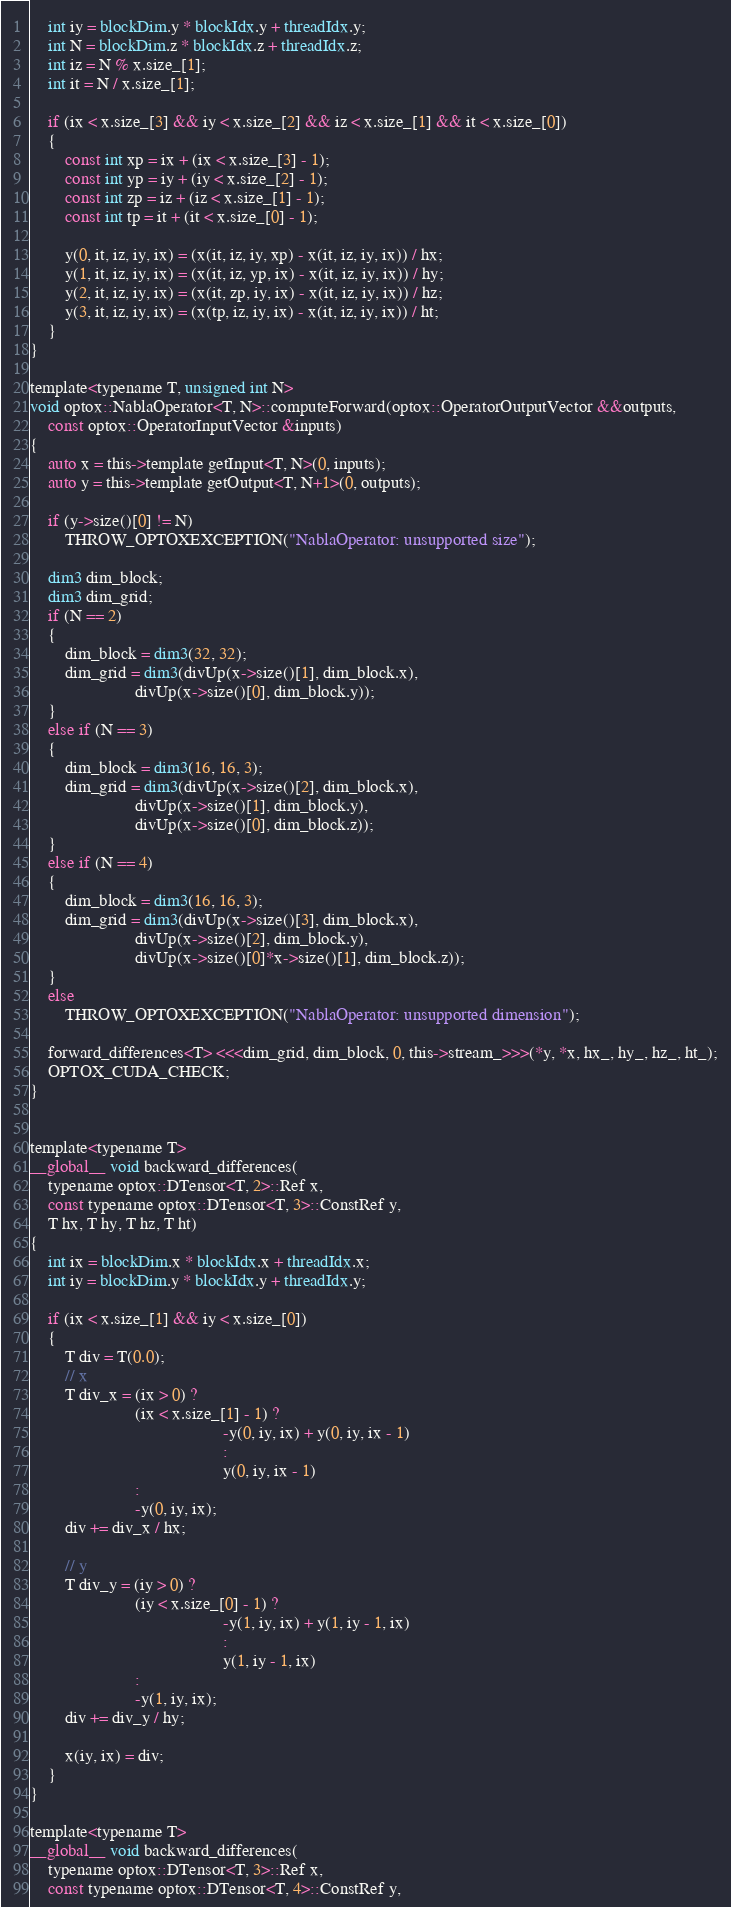Convert code to text. <code><loc_0><loc_0><loc_500><loc_500><_Cuda_>    int iy = blockDim.y * blockIdx.y + threadIdx.y;
    int N = blockDim.z * blockIdx.z + threadIdx.z;
    int iz = N % x.size_[1];
    int it = N / x.size_[1];
  
    if (ix < x.size_[3] && iy < x.size_[2] && iz < x.size_[1] && it < x.size_[0])
    {
        const int xp = ix + (ix < x.size_[3] - 1);
        const int yp = iy + (iy < x.size_[2] - 1);
        const int zp = iz + (iz < x.size_[1] - 1);
        const int tp = it + (it < x.size_[0] - 1);
        
        y(0, it, iz, iy, ix) = (x(it, iz, iy, xp) - x(it, iz, iy, ix)) / hx;
        y(1, it, iz, iy, ix) = (x(it, iz, yp, ix) - x(it, iz, iy, ix)) / hy;
        y(2, it, iz, iy, ix) = (x(it, zp, iy, ix) - x(it, iz, iy, ix)) / hz;
        y(3, it, iz, iy, ix) = (x(tp, iz, iy, ix) - x(it, iz, iy, ix)) / ht;
    }
}

template<typename T, unsigned int N>
void optox::NablaOperator<T, N>::computeForward(optox::OperatorOutputVector &&outputs,
    const optox::OperatorInputVector &inputs)
{
    auto x = this->template getInput<T, N>(0, inputs);
    auto y = this->template getOutput<T, N+1>(0, outputs);

    if (y->size()[0] != N)
        THROW_OPTOXEXCEPTION("NablaOperator: unsupported size");

    dim3 dim_block;
    dim3 dim_grid;
    if (N == 2)
    {
        dim_block = dim3(32, 32);
        dim_grid = dim3(divUp(x->size()[1], dim_block.x),
                        divUp(x->size()[0], dim_block.y));
    }
    else if (N == 3)
    {
        dim_block = dim3(16, 16, 3);
        dim_grid = dim3(divUp(x->size()[2], dim_block.x),
                        divUp(x->size()[1], dim_block.y),
                        divUp(x->size()[0], dim_block.z));
    }
    else if (N == 4)
    {
        dim_block = dim3(16, 16, 3);
        dim_grid = dim3(divUp(x->size()[3], dim_block.x),
                        divUp(x->size()[2], dim_block.y),
                        divUp(x->size()[0]*x->size()[1], dim_block.z));
    }
    else
        THROW_OPTOXEXCEPTION("NablaOperator: unsupported dimension");

    forward_differences<T> <<<dim_grid, dim_block, 0, this->stream_>>>(*y, *x, hx_, hy_, hz_, ht_);
    OPTOX_CUDA_CHECK;
}


template<typename T>
__global__ void backward_differences(
    typename optox::DTensor<T, 2>::Ref x,
    const typename optox::DTensor<T, 3>::ConstRef y,
    T hx, T hy, T hz, T ht)
{
    int ix = blockDim.x * blockIdx.x + threadIdx.x;
    int iy = blockDim.y * blockIdx.y + threadIdx.y;

    if (ix < x.size_[1] && iy < x.size_[0])
    {
        T div = T(0.0);
        // x
        T div_x = (ix > 0) ? 
                        (ix < x.size_[1] - 1) ?
                                            -y(0, iy, ix) + y(0, iy, ix - 1)
                                            :
                                            y(0, iy, ix - 1)
                        :
                        -y(0, iy, ix);
        div += div_x / hx;

        // y
        T div_y = (iy > 0) ? 
                        (iy < x.size_[0] - 1) ?
                                            -y(1, iy, ix) + y(1, iy - 1, ix)
                                            :
                                            y(1, iy - 1, ix)
                        :
                        -y(1, iy, ix);
        div += div_y / hy;

        x(iy, ix) = div;
    }
}

template<typename T>
__global__ void backward_differences(
    typename optox::DTensor<T, 3>::Ref x,
    const typename optox::DTensor<T, 4>::ConstRef y,</code> 